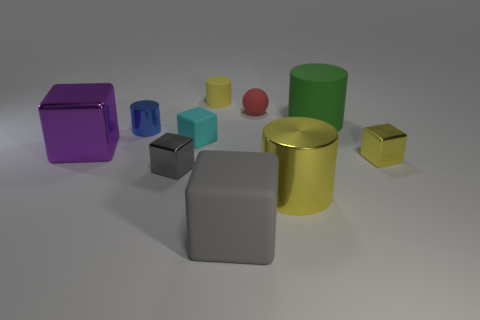Subtract all yellow blocks. How many blocks are left? 4 Subtract 2 cylinders. How many cylinders are left? 2 Subtract all yellow cubes. How many yellow cylinders are left? 2 Subtract all gray blocks. How many blocks are left? 3 Subtract all cylinders. How many objects are left? 6 Add 7 big cubes. How many big cubes are left? 9 Add 6 large green things. How many large green things exist? 7 Subtract 1 yellow cubes. How many objects are left? 9 Subtract all red cylinders. Subtract all green cubes. How many cylinders are left? 4 Subtract all small brown shiny spheres. Subtract all large objects. How many objects are left? 6 